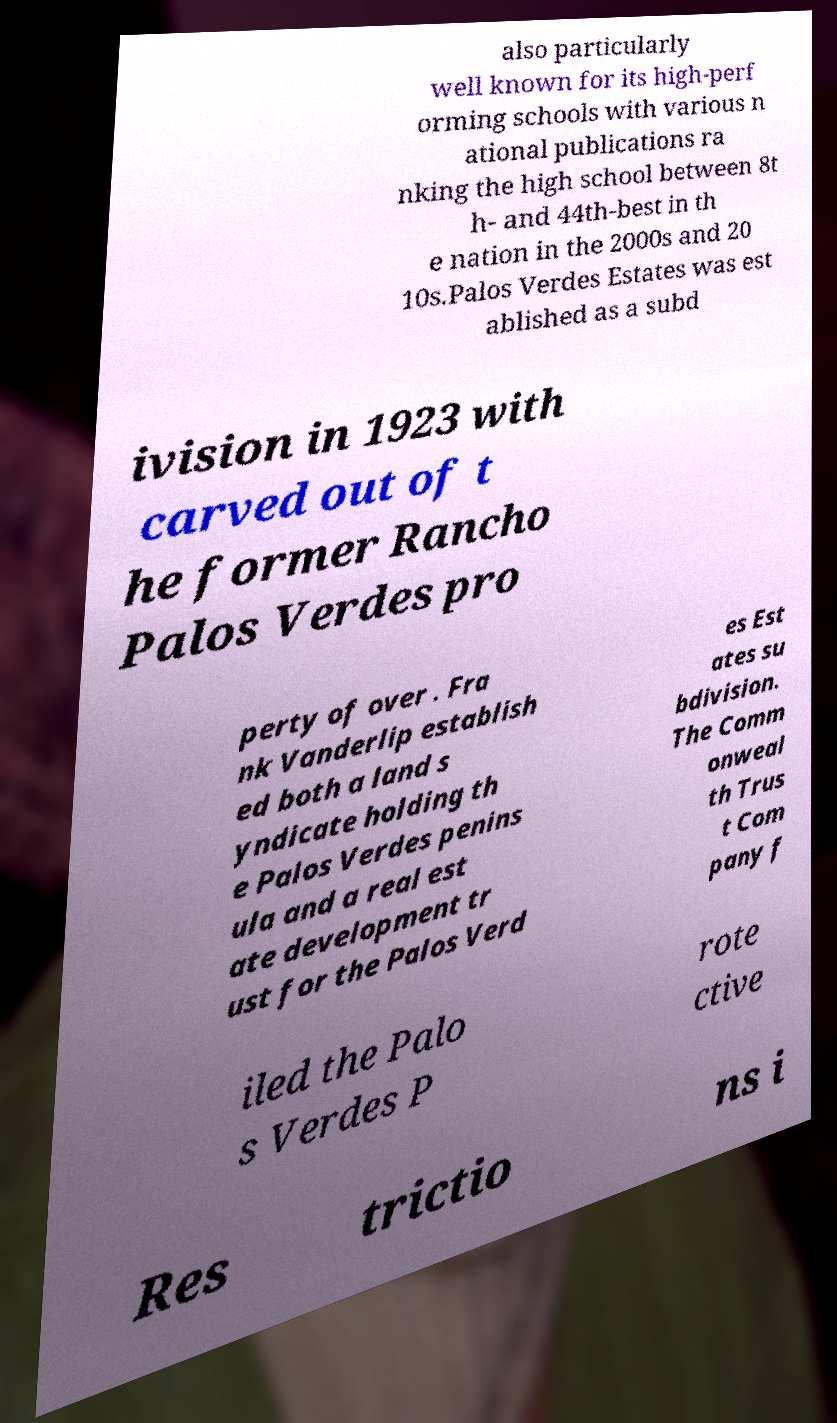Can you read and provide the text displayed in the image?This photo seems to have some interesting text. Can you extract and type it out for me? also particularly well known for its high-perf orming schools with various n ational publications ra nking the high school between 8t h- and 44th-best in th e nation in the 2000s and 20 10s.Palos Verdes Estates was est ablished as a subd ivision in 1923 with carved out of t he former Rancho Palos Verdes pro perty of over . Fra nk Vanderlip establish ed both a land s yndicate holding th e Palos Verdes penins ula and a real est ate development tr ust for the Palos Verd es Est ates su bdivision. The Comm onweal th Trus t Com pany f iled the Palo s Verdes P rote ctive Res trictio ns i 